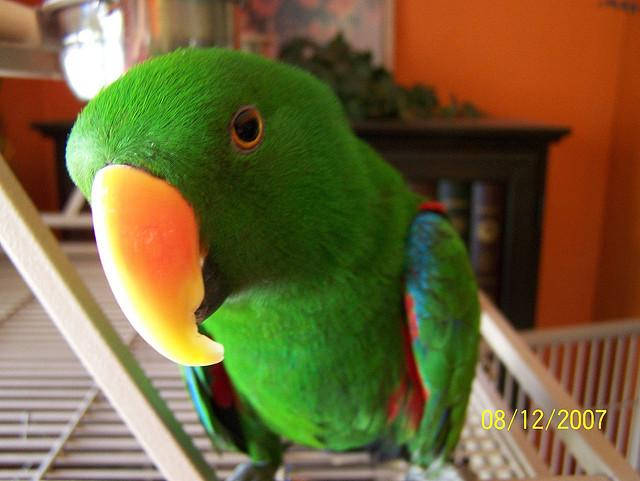Which bird can grind their own calcium supplements? parrot 